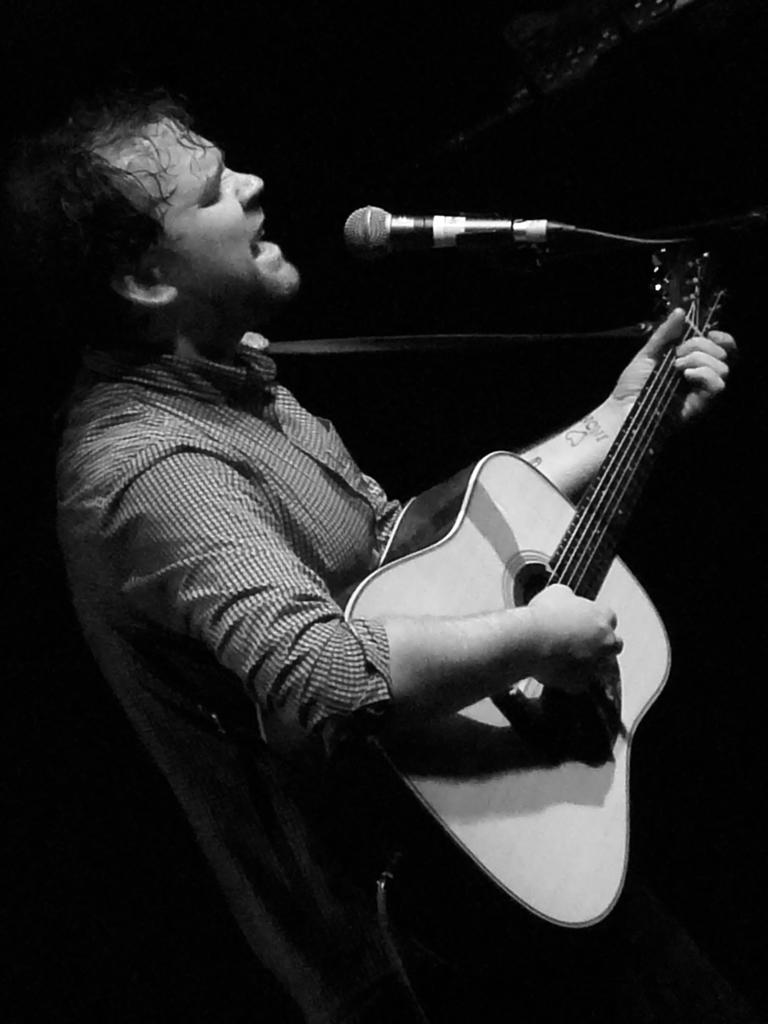Who is the main subject in the image? There is a man in the image. What is the man holding in the image? The man is holding a guitar. What object is in front of the man? There is a microphone in front of the man. What type of digestion can be seen happening to the guitar in the image? There is no digestion happening to the guitar in the image; it is a solid object being held by the man. 